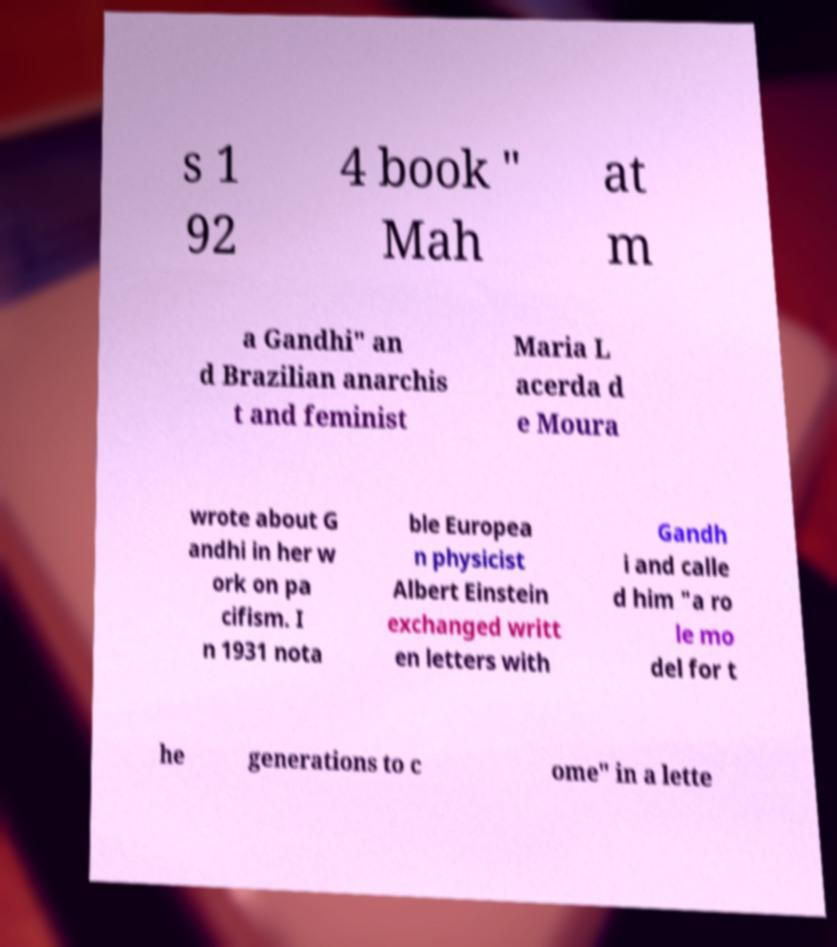Could you assist in decoding the text presented in this image and type it out clearly? s 1 92 4 book " Mah at m a Gandhi" an d Brazilian anarchis t and feminist Maria L acerda d e Moura wrote about G andhi in her w ork on pa cifism. I n 1931 nota ble Europea n physicist Albert Einstein exchanged writt en letters with Gandh i and calle d him "a ro le mo del for t he generations to c ome" in a lette 